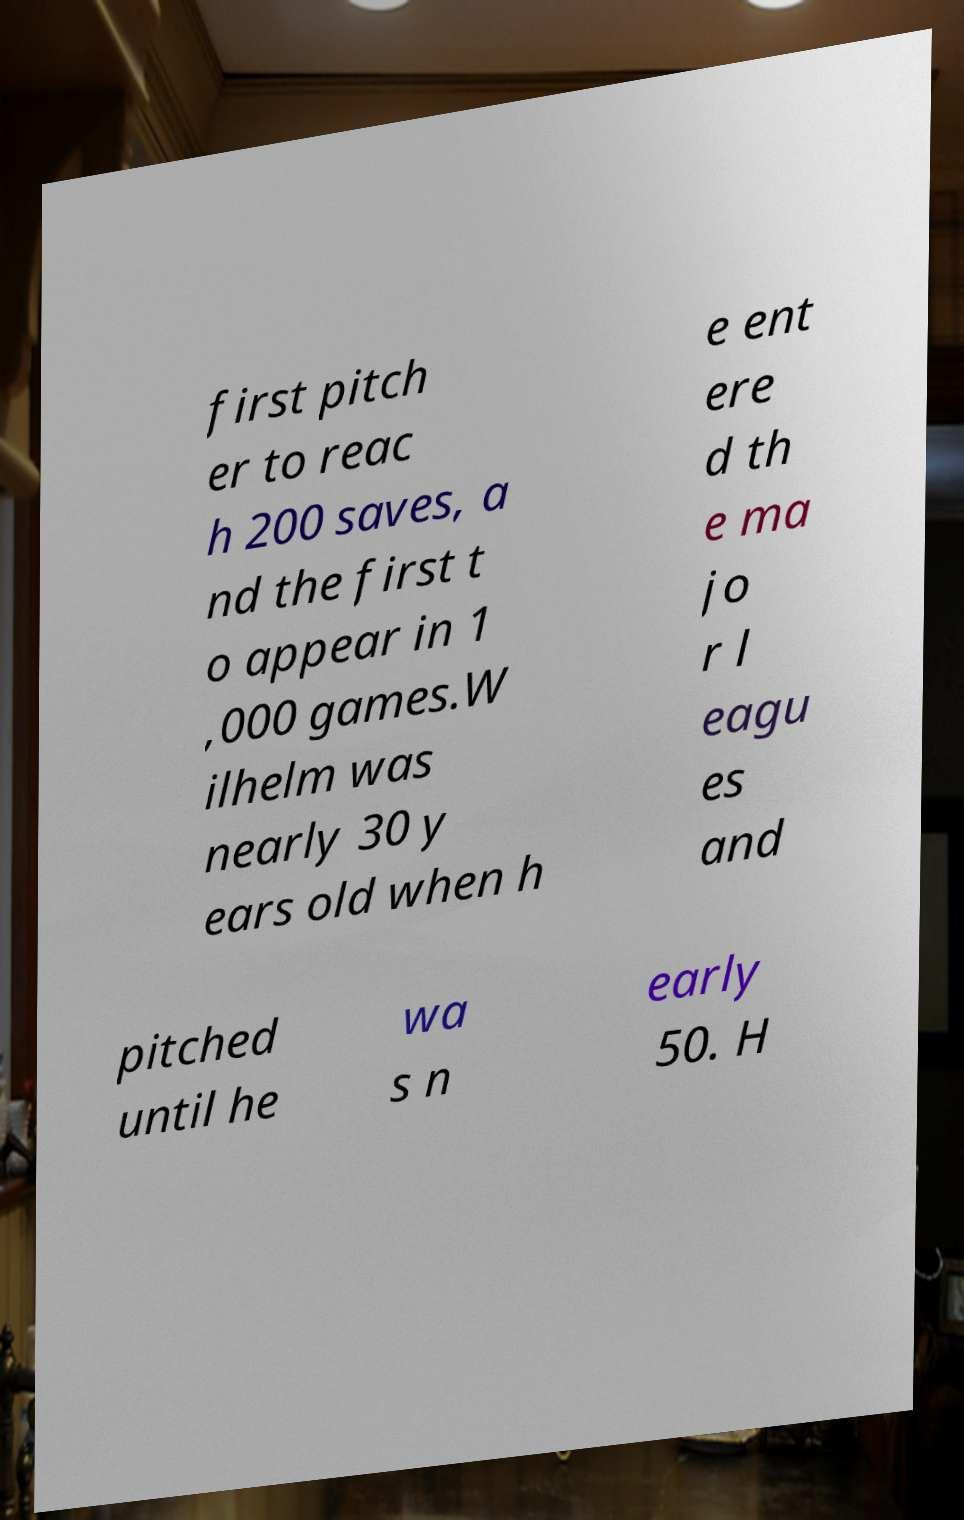Please identify and transcribe the text found in this image. first pitch er to reac h 200 saves, a nd the first t o appear in 1 ,000 games.W ilhelm was nearly 30 y ears old when h e ent ere d th e ma jo r l eagu es and pitched until he wa s n early 50. H 